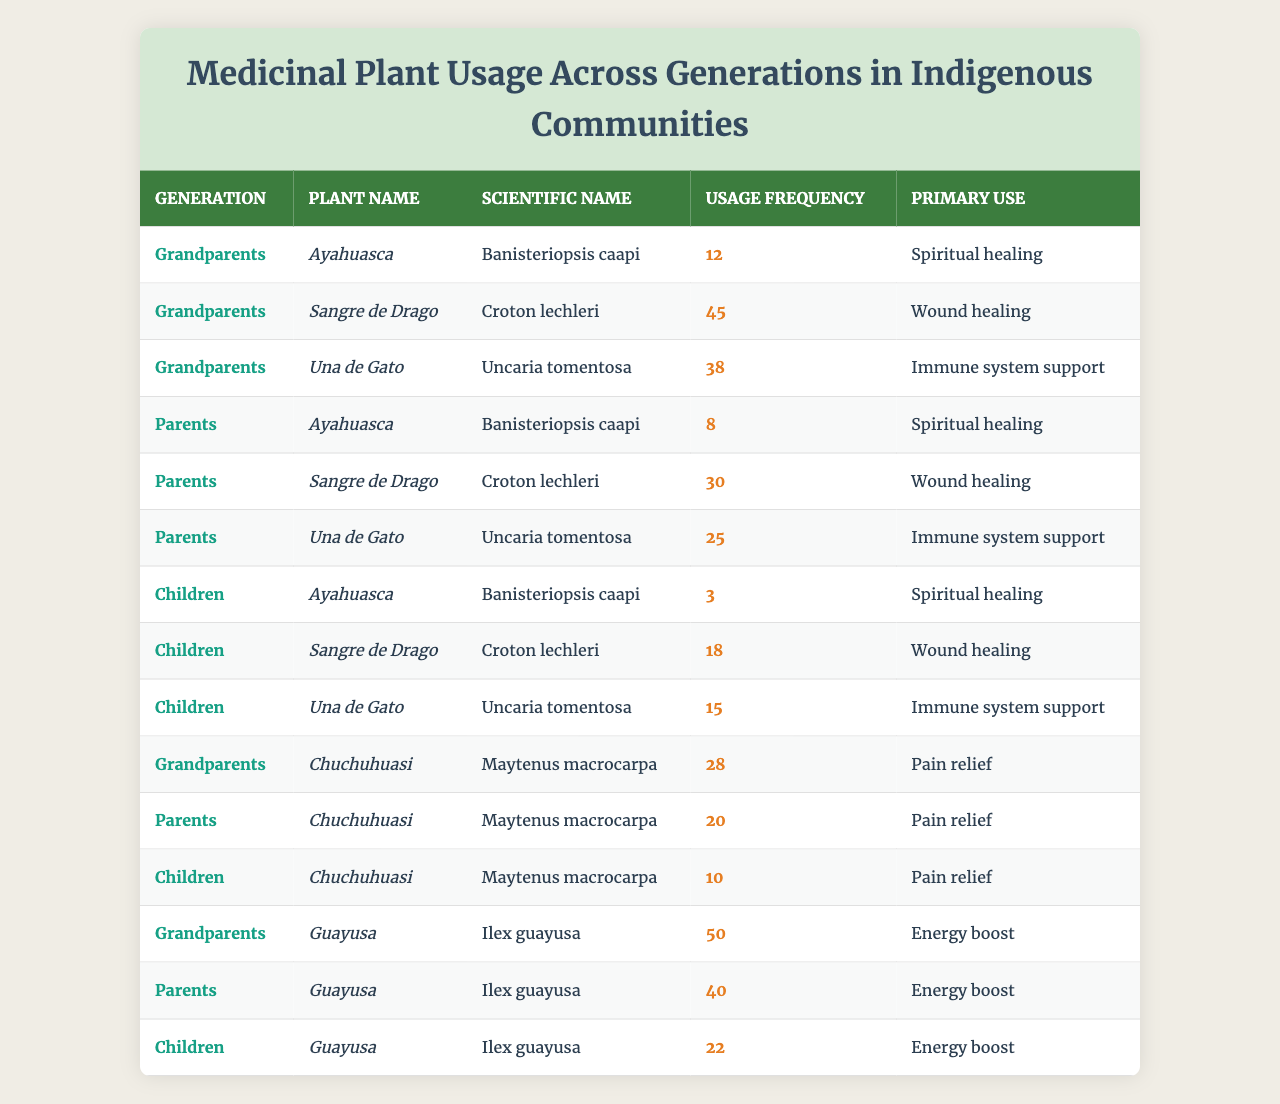What is the most frequently used medicinal plant among the grandparents? The table shows that "Sangre de Drago" is the plant with the highest usage frequency among the grandparents, with a value of 45.
Answer: Sangre de Drago What is the primary use of "Una de Gato"? The primary use of "Una de Gato," according to the table, is "Immune system support."
Answer: Immune system support How many times more frequently is "Guayusa" used by the grandparents compared to the children? For grandparents, the usage frequency of "Guayusa" is 50, while for children it is 22. The difference is 50 - 22 = 28. To find how many times more frequently it is used, we divide: 50 / 22 ≈ 2.27.
Answer: Approximately 2.27 times What is the total usage frequency of "Ayahuasca" across all generations? Adding the usage frequencies from all generations, we find: 12 (grandparents) + 8 (parents) + 3 (children) = 23.
Answer: 23 Is the usage frequency of "Chuchuhuasi" decreasing across generations? The usage frequencies are 28 (grandparents), 20 (parents), and 10 (children). Observing these values shows a consistent decrease from grandparents to parents to children.
Answer: Yes What is the average usage frequency of "Sangre de Drago" across all generations? The usage frequencies are 45 (grandparents), 30 (parents), and 18 (children), summing to 93. The average is 93 divided by 3, which equals 31.
Answer: 31 Which plant has the lowest usage frequency among the children, and what is that frequency? Among the children, "Ayahuasca" has the lowest usage frequency at 3.
Answer: Ayahuasca, 3 What is the difference in usage frequency of "Guayusa" between grandparents and parents? The usage frequency for grandparents is 50, and for parents is 40. The difference is 50 - 40 = 10.
Answer: 10 What percentage decrease in usage frequency of "Una de Gato" is observed from grandparents to children? The usage frequency for grandparents is 38 and for children it is 15. The decrease is 38 - 15 = 23. To find the percentage decrease, we divide the decrease by the original value: (23 / 38) * 100 ≈ 60.53%.
Answer: Approximately 60.53% Are there any plants that have the same usage frequency in different generations? Upon examining the table, "Chuchuhuasi" has 20 in parents and 10 in children, while all others have different frequencies across the generations. Therefore, no plants have the same frequency across generations.
Answer: No 